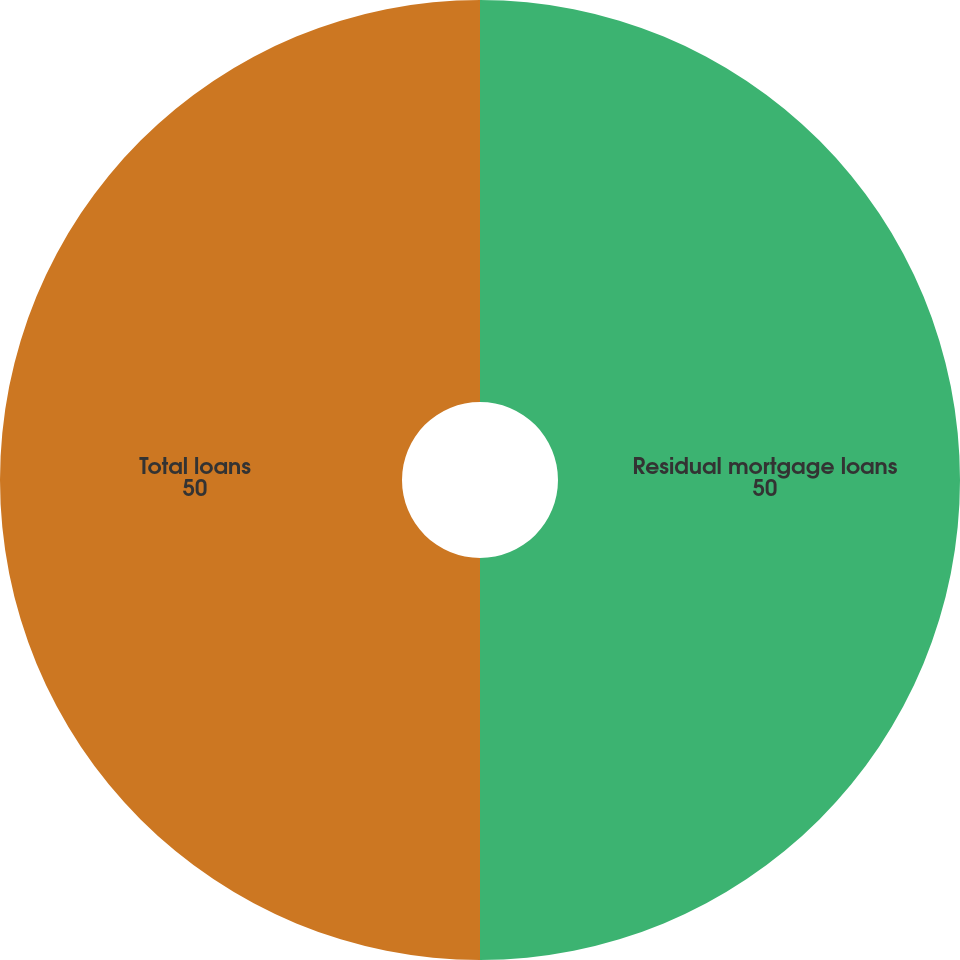Convert chart to OTSL. <chart><loc_0><loc_0><loc_500><loc_500><pie_chart><fcel>Residual mortgage loans<fcel>Total loans<nl><fcel>50.0%<fcel>50.0%<nl></chart> 